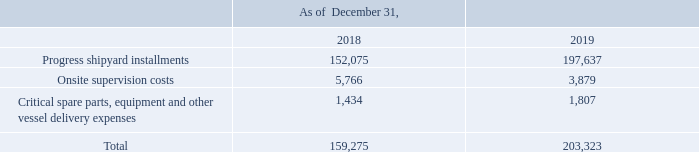GasLog Ltd. and its Subsidiaries
Notes to the consolidated financial statements (Continued)
For the years ended December 31, 2017, 2018 and 2019
(All amounts expressed in thousands of U.S. Dollars, except share and per share data)
Vessels under construction represent scheduled advance payments to the shipyards as well as certain capitalized expenditures. As of December 31, 2019, the Group has paid to the shipyard $197,637 for the vessels that are under construction and expects to pay the remaining installments as they come due upon each vessel’s keel laying, launching and delivery (Note 23(a)).
The vessels under construction costs as of December 31, 2018 and 2019 are comprised of:
In which years was the vessels under construction costs recorded for? 2018, 2019. What does vessels under construction represent? Scheduled advance payments to the shipyards as well as certain capitalized expenditures. How much has the Group paid for the progress shipyard installments in 2019?
Answer scale should be: thousand. $197,637. Which year was the progress shipyard installments lower? 152,075 < 197,637
Answer: 2018. What was the change in onsite supervision costs  from 2018 to 2019 ?
Answer scale should be: thousand. 3,879 - 5,766 
Answer: -1887. What was the percentage change in total cost from 2018 to 2019?
Answer scale should be: percent. (203,323 - 159,275)/159,275 
Answer: 27.66. 